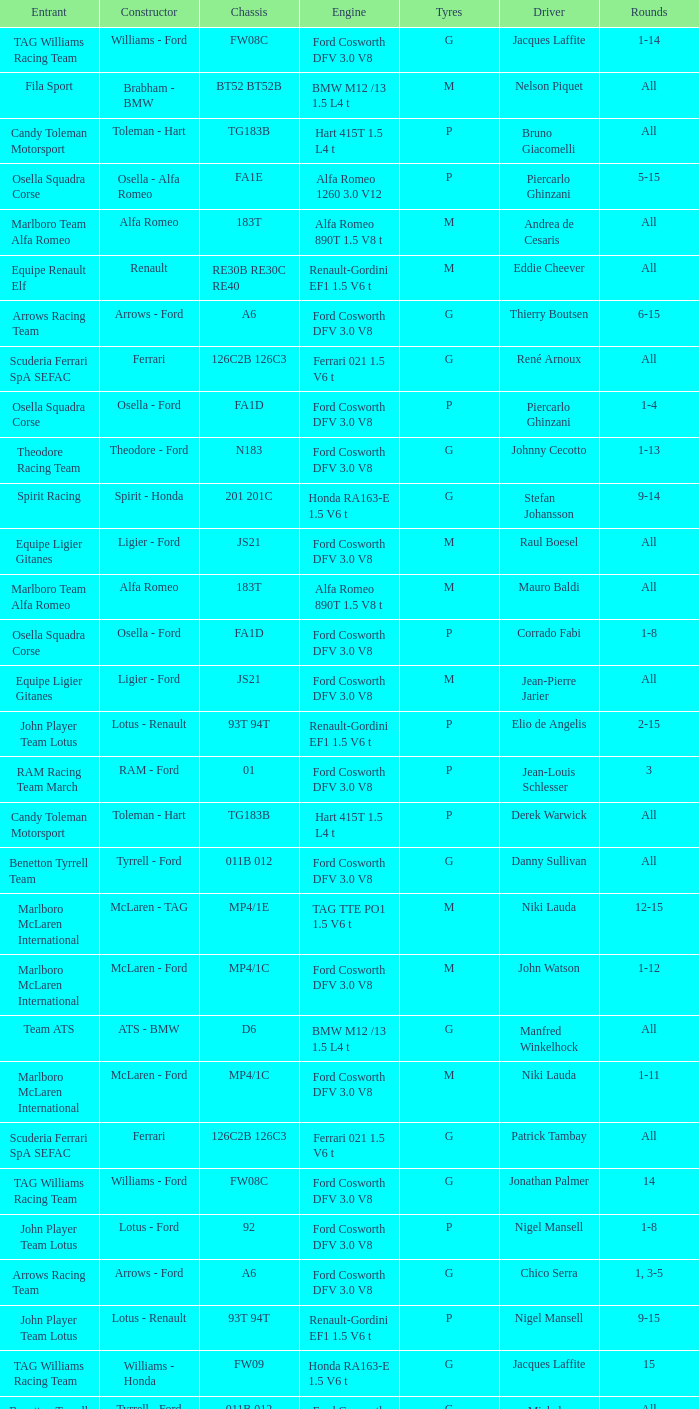Who is the Constructor for driver Piercarlo Ghinzani and a Ford cosworth dfv 3.0 v8 engine? Osella - Ford. 